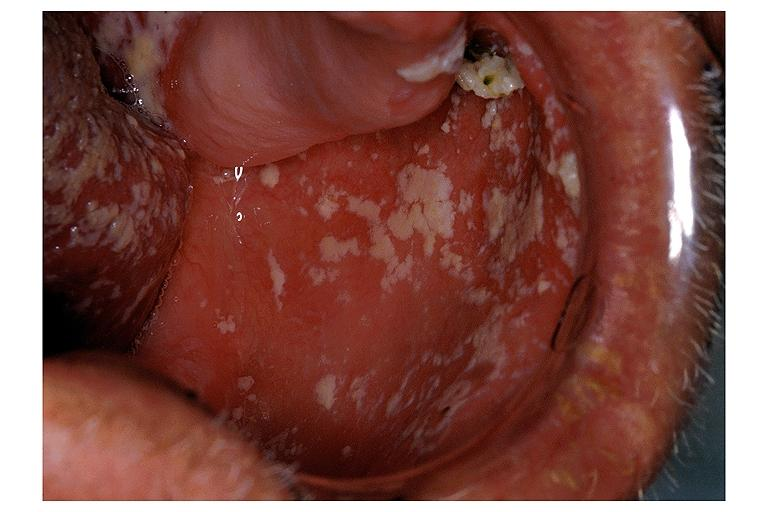s yo present?
Answer the question using a single word or phrase. No 